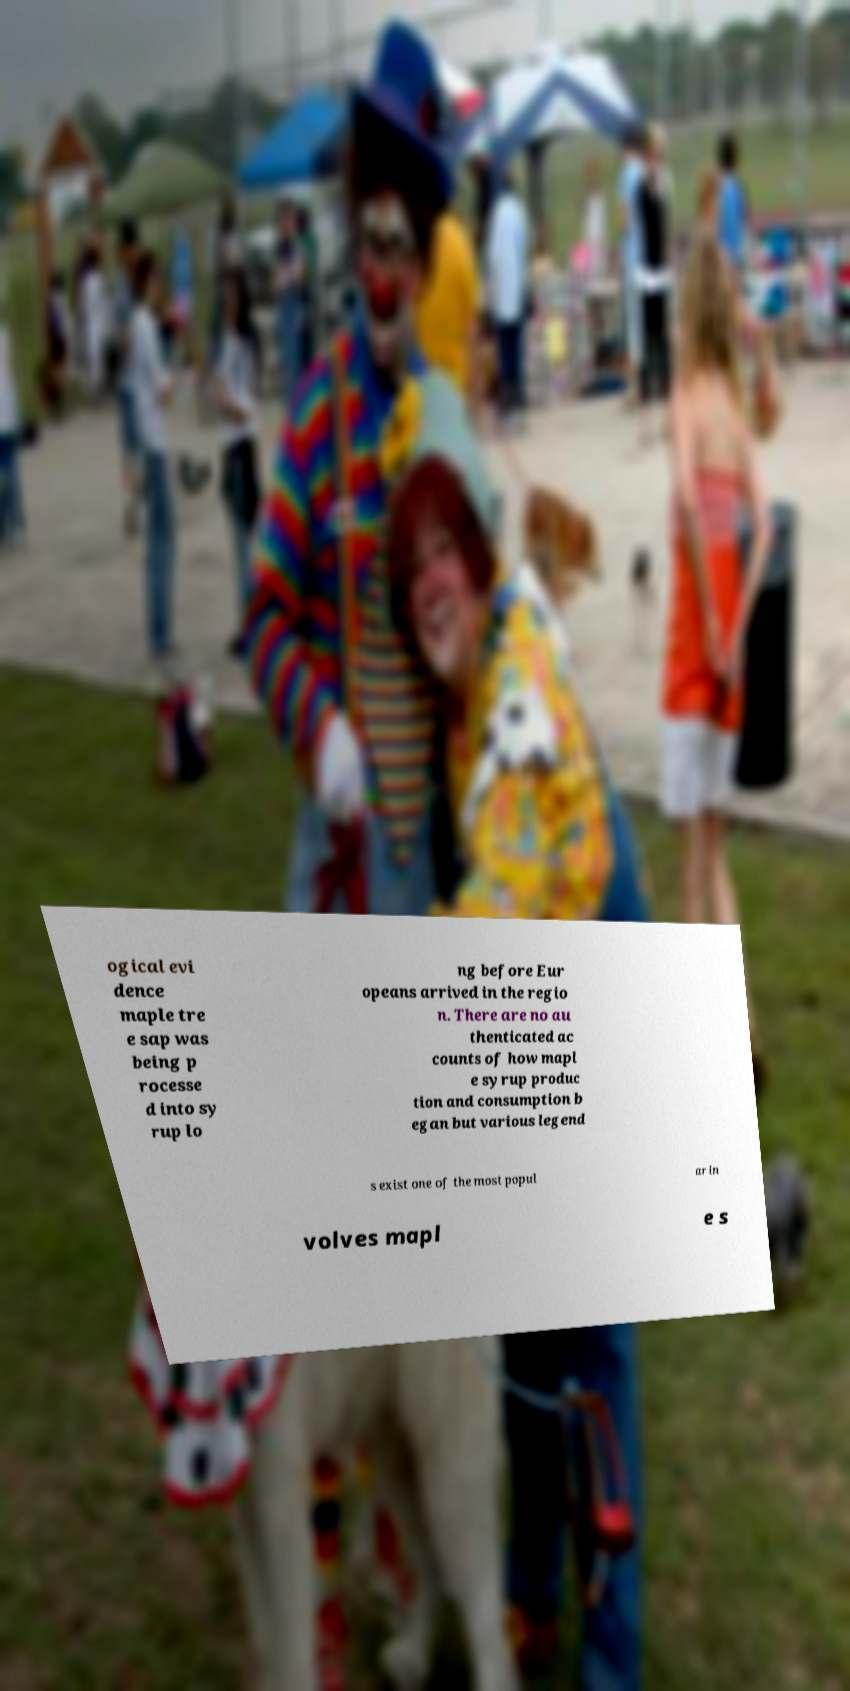Could you assist in decoding the text presented in this image and type it out clearly? ogical evi dence maple tre e sap was being p rocesse d into sy rup lo ng before Eur opeans arrived in the regio n. There are no au thenticated ac counts of how mapl e syrup produc tion and consumption b egan but various legend s exist one of the most popul ar in volves mapl e s 